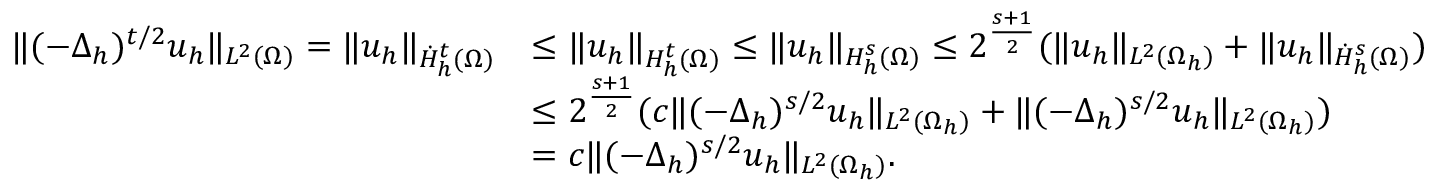<formula> <loc_0><loc_0><loc_500><loc_500>\begin{array} { r l } { \| ( - \Delta _ { h } ) ^ { t / 2 } u _ { h } \| _ { L ^ { 2 } ( \Omega ) } = \| u _ { h } \| _ { \dot { H } _ { h } ^ { t } ( \Omega ) } } & { \leq \| u _ { h } \| _ { H _ { h } ^ { t } ( \Omega ) } \leq \| u _ { h } \| _ { H _ { h } ^ { s } ( \Omega ) } \leq 2 ^ { \frac { s + 1 } { 2 } } ( \| u _ { h } \| _ { L ^ { 2 } ( \Omega _ { h } ) } + \| u _ { h } \| _ { \dot { H } _ { h } ^ { s } ( \Omega ) } ) } \\ & { \leq 2 ^ { \frac { s + 1 } { 2 } } ( c \| ( - \Delta _ { h } ) ^ { s / 2 } u _ { h } \| _ { L ^ { 2 } ( \Omega _ { h } ) } + \| ( - \Delta _ { h } ) ^ { s / 2 } u _ { h } \| _ { L ^ { 2 } ( \Omega _ { h } ) } ) } \\ & { = { c } \| ( - \Delta _ { h } ) ^ { s / 2 } u _ { h } \| _ { L ^ { 2 } ( \Omega _ { h } ) } . } \end{array}</formula> 